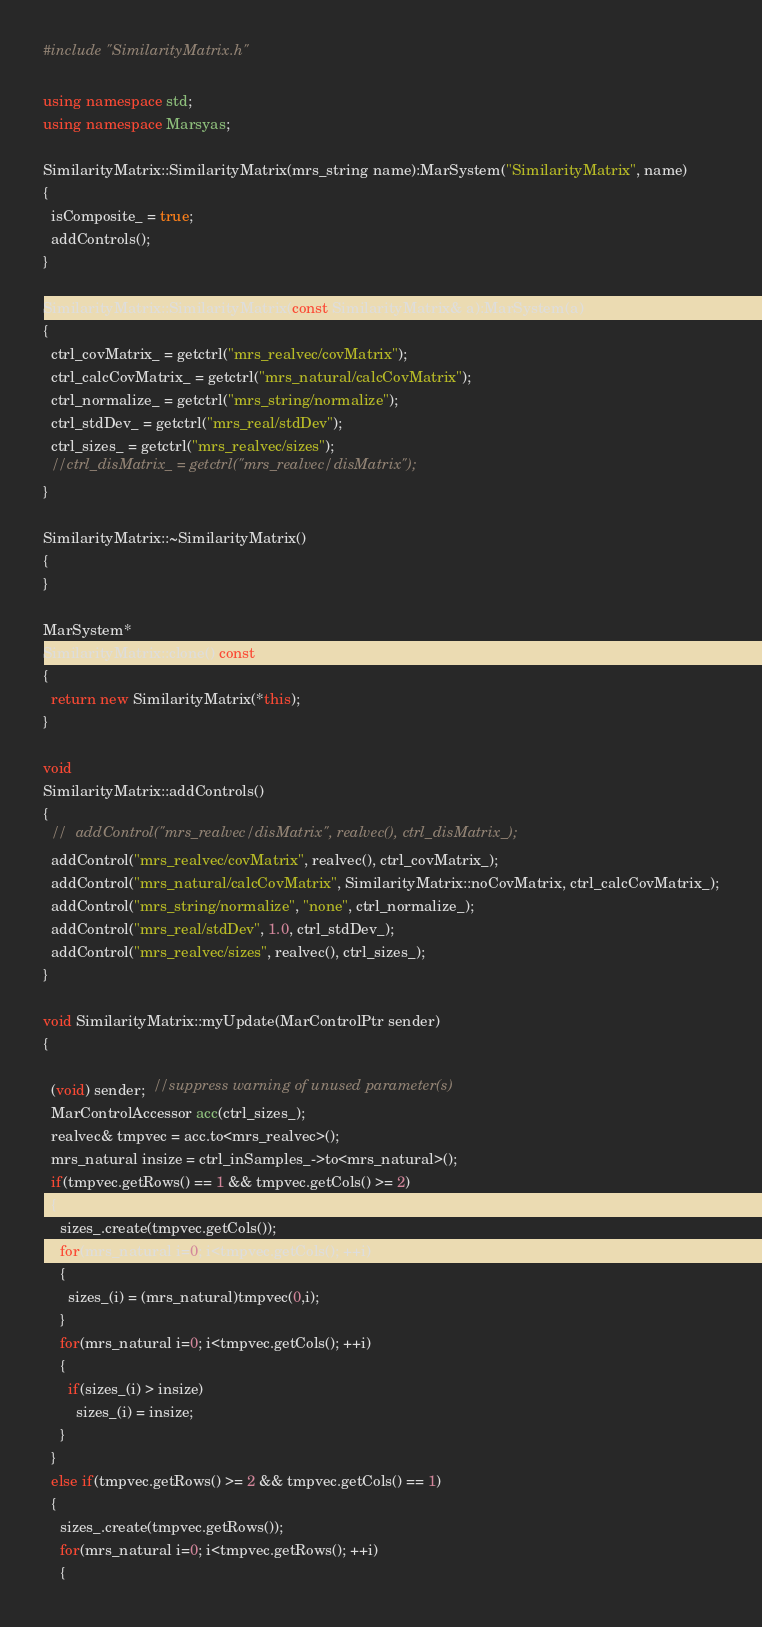<code> <loc_0><loc_0><loc_500><loc_500><_C++_>#include "SimilarityMatrix.h"

using namespace std;
using namespace Marsyas;

SimilarityMatrix::SimilarityMatrix(mrs_string name):MarSystem("SimilarityMatrix", name)
{
  isComposite_ = true;
  addControls();
}

SimilarityMatrix::SimilarityMatrix(const SimilarityMatrix& a):MarSystem(a)
{
  ctrl_covMatrix_ = getctrl("mrs_realvec/covMatrix");
  ctrl_calcCovMatrix_ = getctrl("mrs_natural/calcCovMatrix");
  ctrl_normalize_ = getctrl("mrs_string/normalize");
  ctrl_stdDev_ = getctrl("mrs_real/stdDev");
  ctrl_sizes_ = getctrl("mrs_realvec/sizes");
  //ctrl_disMatrix_ = getctrl("mrs_realvec/disMatrix");
}

SimilarityMatrix::~SimilarityMatrix()
{
}

MarSystem*
SimilarityMatrix::clone() const
{
  return new SimilarityMatrix(*this);
}

void
SimilarityMatrix::addControls()
{
  //  addControl("mrs_realvec/disMatrix", realvec(), ctrl_disMatrix_);
  addControl("mrs_realvec/covMatrix", realvec(), ctrl_covMatrix_);
  addControl("mrs_natural/calcCovMatrix", SimilarityMatrix::noCovMatrix, ctrl_calcCovMatrix_);
  addControl("mrs_string/normalize", "none", ctrl_normalize_);
  addControl("mrs_real/stdDev", 1.0, ctrl_stdDev_);
  addControl("mrs_realvec/sizes", realvec(), ctrl_sizes_);
}

void SimilarityMatrix::myUpdate(MarControlPtr sender)
{

  (void) sender;  //suppress warning of unused parameter(s)
  MarControlAccessor acc(ctrl_sizes_);
  realvec& tmpvec = acc.to<mrs_realvec>();
  mrs_natural insize = ctrl_inSamples_->to<mrs_natural>();
  if(tmpvec.getRows() == 1 && tmpvec.getCols() >= 2)
  {
    sizes_.create(tmpvec.getCols());
    for(mrs_natural i=0; i<tmpvec.getCols(); ++i)
    {
      sizes_(i) = (mrs_natural)tmpvec(0,i);
    }
    for(mrs_natural i=0; i<tmpvec.getCols(); ++i)
    {
      if(sizes_(i) > insize)
        sizes_(i) = insize;
    }
  }
  else if(tmpvec.getRows() >= 2 && tmpvec.getCols() == 1)
  {
    sizes_.create(tmpvec.getRows());
    for(mrs_natural i=0; i<tmpvec.getRows(); ++i)
    {</code> 